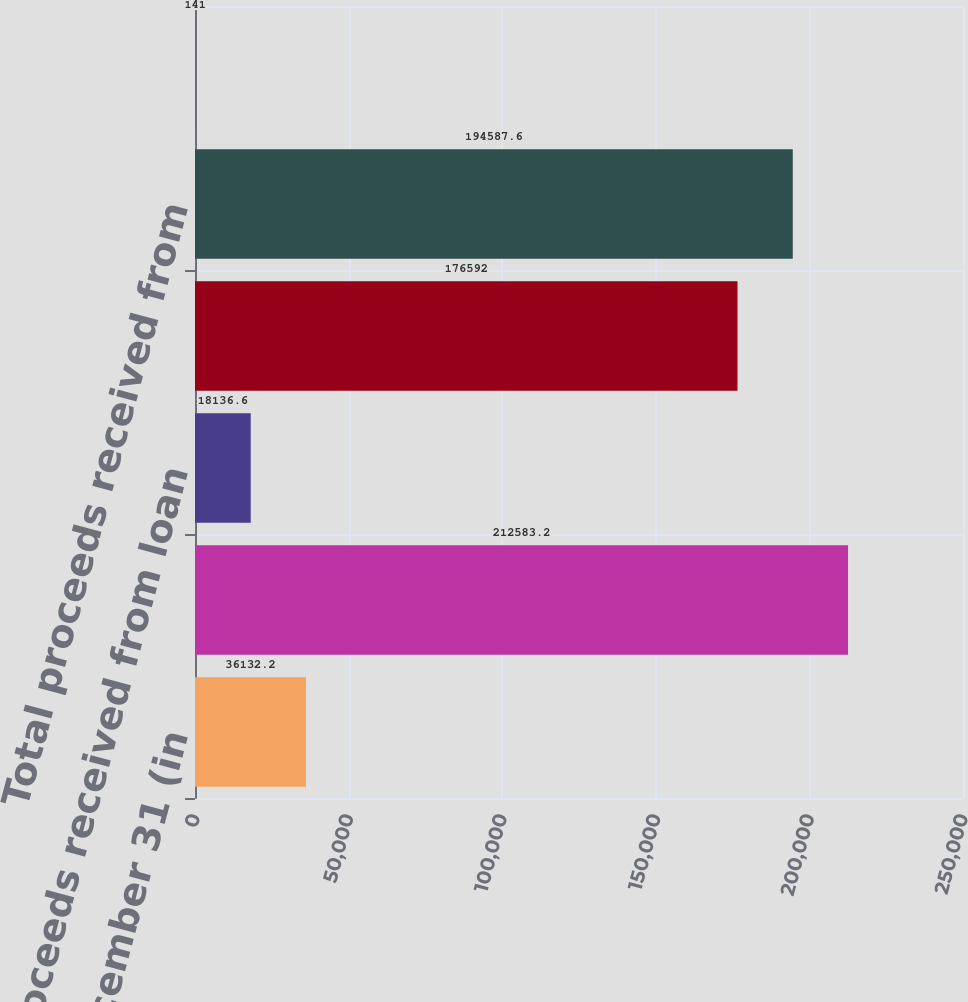Convert chart to OTSL. <chart><loc_0><loc_0><loc_500><loc_500><bar_chart><fcel>Year ended December 31 (in<fcel>Carrying value of loans sold<fcel>Proceeds received from loan<fcel>Proceeds from loan sales as<fcel>Total proceeds received from<fcel>Gains on loan sales (d)<nl><fcel>36132.2<fcel>212583<fcel>18136.6<fcel>176592<fcel>194588<fcel>141<nl></chart> 